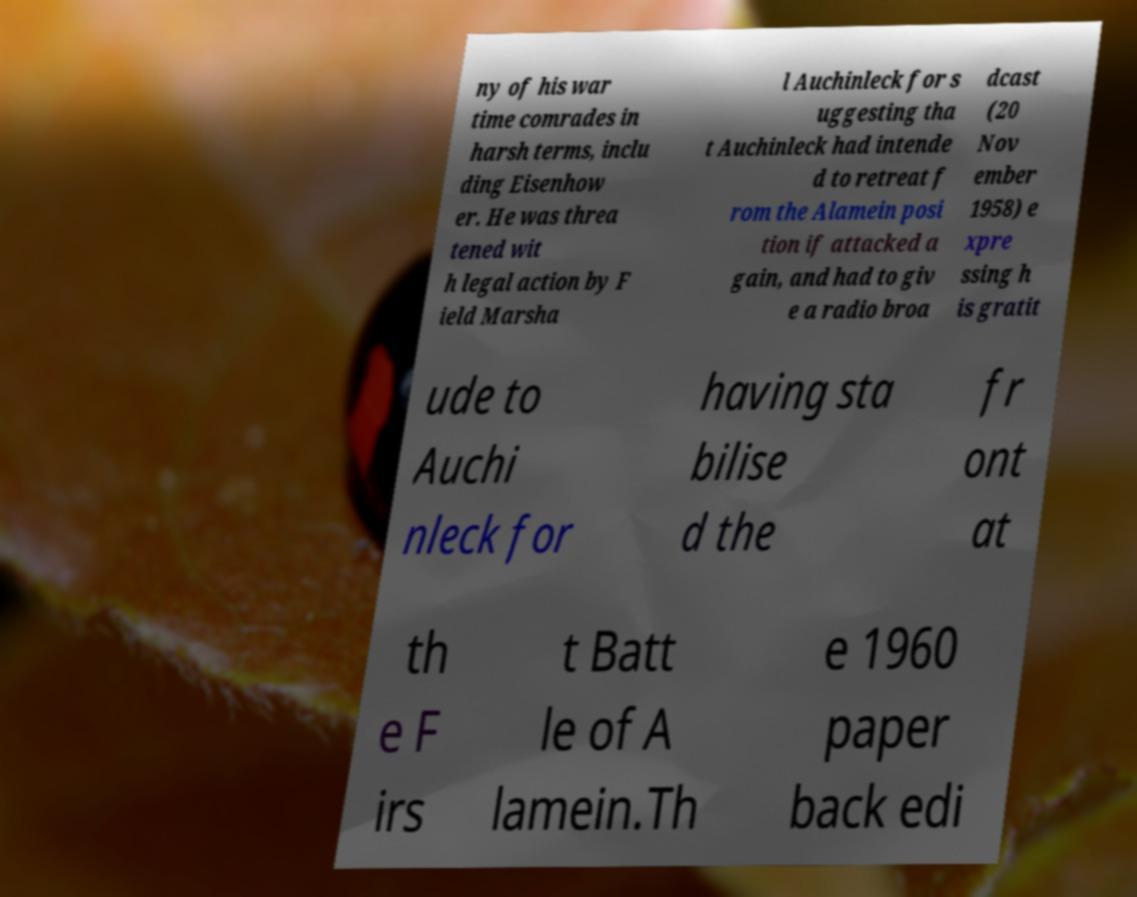There's text embedded in this image that I need extracted. Can you transcribe it verbatim? ny of his war time comrades in harsh terms, inclu ding Eisenhow er. He was threa tened wit h legal action by F ield Marsha l Auchinleck for s uggesting tha t Auchinleck had intende d to retreat f rom the Alamein posi tion if attacked a gain, and had to giv e a radio broa dcast (20 Nov ember 1958) e xpre ssing h is gratit ude to Auchi nleck for having sta bilise d the fr ont at th e F irs t Batt le of A lamein.Th e 1960 paper back edi 